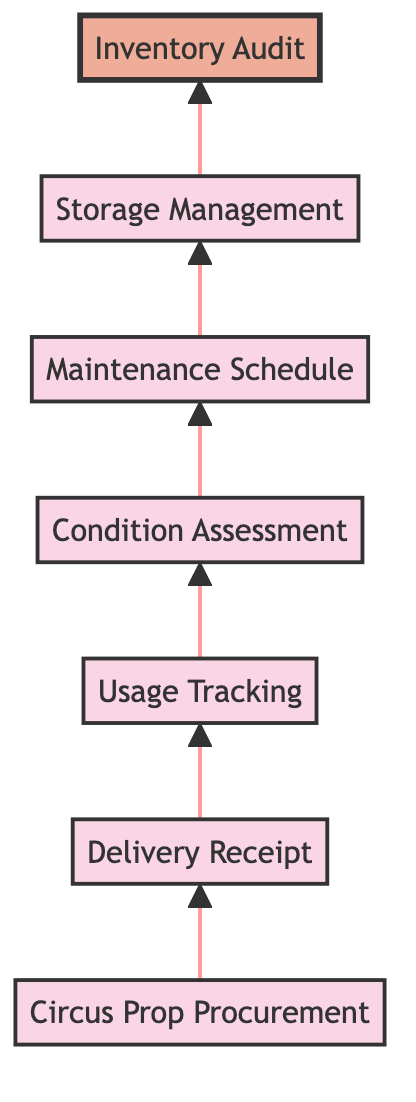What's the first step in the inventory management flow? The first step in the flow is "Circus Prop Procurement," which involves identifying and ordering props based on upcoming performances.
Answer: Circus Prop Procurement How many nodes are in the flowchart? The flowchart contains a total of 7 nodes that represent different steps in the inventory management process for circus props and equipment.
Answer: 7 What comes after "Delivery Receipt"? Following "Delivery Receipt," the next step in the flow is "Usage Tracking," where the use of props is logged and monitored during rehearsals and performances.
Answer: Usage Tracking Which step evaluates the condition of props? The step that evaluates the condition of props and equipment for safety and functionality is "Condition Assessment."
Answer: Condition Assessment What is the final step in the inventory management flow? The final step of the inventory management flow is "Inventory Audit," which conducts periodic audits to reconcile the actual inventory with records.
Answer: Inventory Audit What are the two steps before "Maintenance Schedule"? The two steps before "Maintenance Schedule" are "Condition Assessment" and "Usage Tracking." It involves tracking usage followed by assessing the condition of the props.
Answer: Condition Assessment and Usage Tracking What serves as a link between "Storage Management" and "Inventory Audit"? The link between "Storage Management" and "Inventory Audit" is the flow from the storage process to the final audit process, indicating a sequential transition.
Answer: Storage Management Which step involves organizing and storing props and equipment? The step that involves organizing and storing props and equipment after use is "Storage Management."
Answer: Storage Management How does the flowchart suggest assessing prope condition? The flowchart suggests assessing the condition of props through the "Condition Assessment" step, which involves regular evaluations for safety and functionality.
Answer: Condition Assessment 